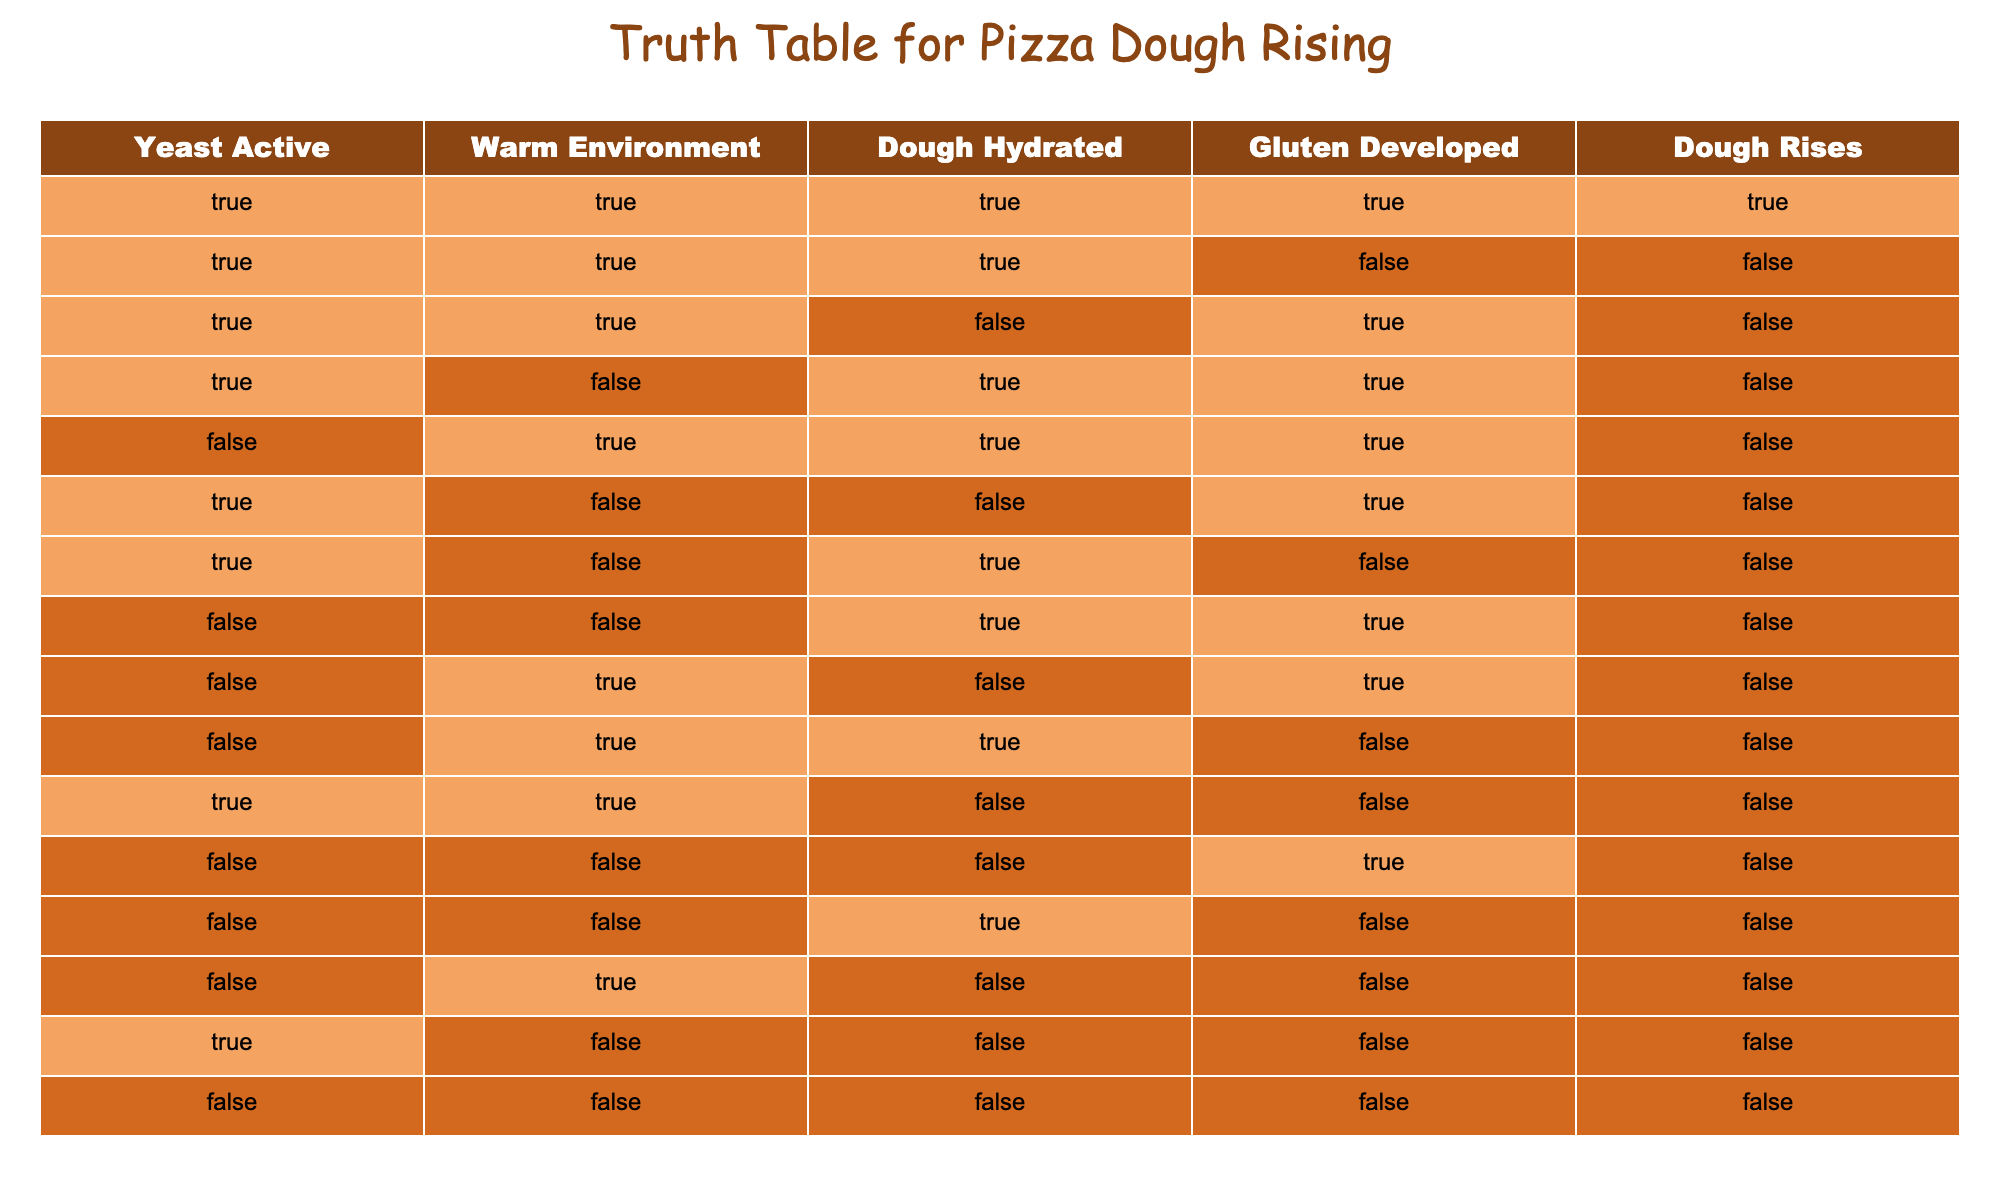What is the result when both Yeast Active and Warm Environment are true? In the table, looking at the entries where "Yeast Active" and "Warm Environment" are both true, I can see three rows: one where "Dough Rises" is true, and two where it is false. Thus, the result is that dough only rises under these conditions in one specific case.
Answer: The dough rises How many conditions lead to the dough rising? I need to count the rows in the table where "Dough Rises" is true. Upon review, there is one row where that condition is satisfied, which indicates that only one combination of the preceding conditions leads to the dough rising.
Answer: One Does dough rise if yeast is inactive regardless of other conditions? I look at the rows where "Yeast Active" is false. In all these instances, the "Dough Rises" column shows that the dough does not rise. Hence, the answer to whether the dough can rise under such conditions is no, as the inactive yeast leads to the dough not rising.
Answer: No If the environment is warm and gluten is developed, does the dough rise when the yeast is active? I will find the rows meeting these two conditions, namely: "Warm Environment" is true and "Gluten Developed" is true while "Yeast Active" is also true. There is one row that confirms this has a "Dough Rises" status of true, showing this combination allows the dough to rise.
Answer: Yes What happens to the dough if it is hydrated but missing gluten? I check the rows where "Dough Hydrated" is true and "Gluten Developed" is false. In that case, I find a specific row where the dough does not rise. This indicates that gluten is essential despite other conditions being met for rising to occur.
Answer: The dough does not rise 